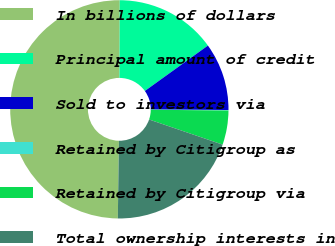Convert chart to OTSL. <chart><loc_0><loc_0><loc_500><loc_500><pie_chart><fcel>In billions of dollars<fcel>Principal amount of credit<fcel>Sold to investors via<fcel>Retained by Citigroup as<fcel>Retained by Citigroup via<fcel>Total ownership interests in<nl><fcel>49.83%<fcel>15.01%<fcel>10.03%<fcel>0.08%<fcel>5.06%<fcel>19.98%<nl></chart> 